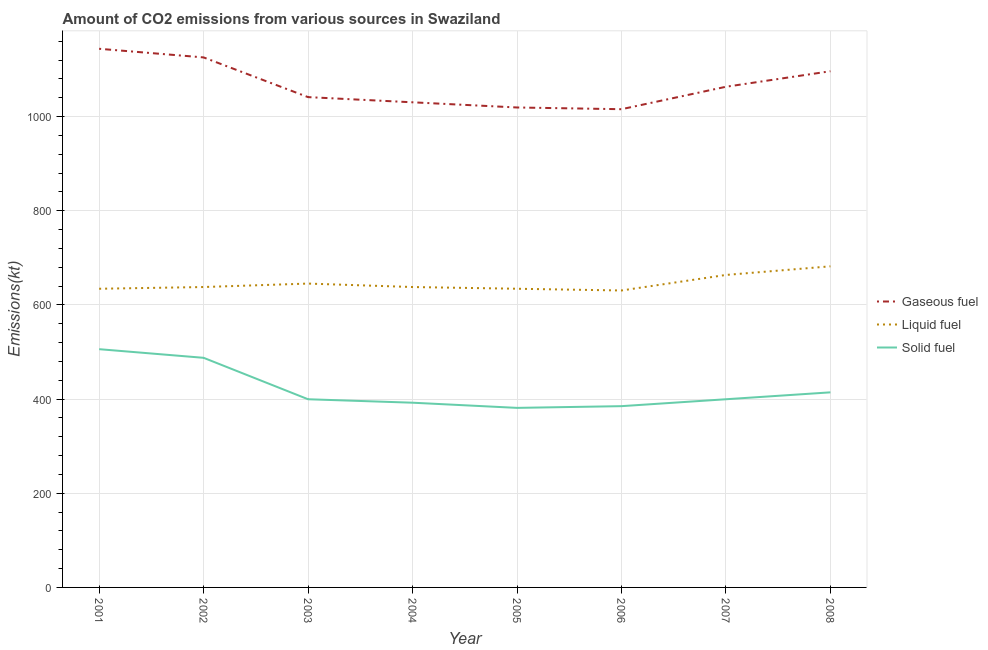How many different coloured lines are there?
Give a very brief answer. 3. Is the number of lines equal to the number of legend labels?
Your answer should be compact. Yes. What is the amount of co2 emissions from solid fuel in 2001?
Keep it short and to the point. 506.05. Across all years, what is the maximum amount of co2 emissions from liquid fuel?
Give a very brief answer. 682.06. Across all years, what is the minimum amount of co2 emissions from gaseous fuel?
Provide a succinct answer. 1015.76. In which year was the amount of co2 emissions from solid fuel maximum?
Offer a very short reply. 2001. In which year was the amount of co2 emissions from solid fuel minimum?
Your answer should be compact. 2005. What is the total amount of co2 emissions from solid fuel in the graph?
Offer a terse response. 3366.31. What is the difference between the amount of co2 emissions from solid fuel in 2003 and that in 2005?
Offer a very short reply. 18.33. What is the difference between the amount of co2 emissions from gaseous fuel in 2007 and the amount of co2 emissions from liquid fuel in 2006?
Offer a terse response. 432.71. What is the average amount of co2 emissions from gaseous fuel per year?
Your answer should be compact. 1067.1. In the year 2003, what is the difference between the amount of co2 emissions from gaseous fuel and amount of co2 emissions from liquid fuel?
Offer a very short reply. 396.04. In how many years, is the amount of co2 emissions from liquid fuel greater than 1000 kt?
Keep it short and to the point. 0. What is the ratio of the amount of co2 emissions from liquid fuel in 2002 to that in 2004?
Your response must be concise. 1. What is the difference between the highest and the second highest amount of co2 emissions from solid fuel?
Your answer should be compact. 18.33. What is the difference between the highest and the lowest amount of co2 emissions from gaseous fuel?
Offer a very short reply. 128.35. Is it the case that in every year, the sum of the amount of co2 emissions from gaseous fuel and amount of co2 emissions from liquid fuel is greater than the amount of co2 emissions from solid fuel?
Give a very brief answer. Yes. How many lines are there?
Make the answer very short. 3. How many years are there in the graph?
Offer a terse response. 8. What is the difference between two consecutive major ticks on the Y-axis?
Keep it short and to the point. 200. Are the values on the major ticks of Y-axis written in scientific E-notation?
Provide a short and direct response. No. Where does the legend appear in the graph?
Keep it short and to the point. Center right. How are the legend labels stacked?
Offer a terse response. Vertical. What is the title of the graph?
Give a very brief answer. Amount of CO2 emissions from various sources in Swaziland. What is the label or title of the Y-axis?
Your answer should be compact. Emissions(kt). What is the Emissions(kt) in Gaseous fuel in 2001?
Your response must be concise. 1144.1. What is the Emissions(kt) in Liquid fuel in 2001?
Offer a very short reply. 634.39. What is the Emissions(kt) of Solid fuel in 2001?
Ensure brevity in your answer.  506.05. What is the Emissions(kt) in Gaseous fuel in 2002?
Provide a succinct answer. 1125.77. What is the Emissions(kt) in Liquid fuel in 2002?
Offer a very short reply. 638.06. What is the Emissions(kt) of Solid fuel in 2002?
Your answer should be very brief. 487.71. What is the Emissions(kt) in Gaseous fuel in 2003?
Your response must be concise. 1041.43. What is the Emissions(kt) of Liquid fuel in 2003?
Provide a succinct answer. 645.39. What is the Emissions(kt) in Solid fuel in 2003?
Make the answer very short. 399.7. What is the Emissions(kt) of Gaseous fuel in 2004?
Make the answer very short. 1030.43. What is the Emissions(kt) of Liquid fuel in 2004?
Give a very brief answer. 638.06. What is the Emissions(kt) in Solid fuel in 2004?
Provide a succinct answer. 392.37. What is the Emissions(kt) in Gaseous fuel in 2005?
Provide a short and direct response. 1019.43. What is the Emissions(kt) of Liquid fuel in 2005?
Ensure brevity in your answer.  634.39. What is the Emissions(kt) in Solid fuel in 2005?
Give a very brief answer. 381.37. What is the Emissions(kt) in Gaseous fuel in 2006?
Provide a succinct answer. 1015.76. What is the Emissions(kt) of Liquid fuel in 2006?
Provide a succinct answer. 630.72. What is the Emissions(kt) in Solid fuel in 2006?
Your response must be concise. 385.04. What is the Emissions(kt) in Gaseous fuel in 2007?
Offer a terse response. 1063.43. What is the Emissions(kt) in Liquid fuel in 2007?
Ensure brevity in your answer.  663.73. What is the Emissions(kt) in Solid fuel in 2007?
Give a very brief answer. 399.7. What is the Emissions(kt) of Gaseous fuel in 2008?
Ensure brevity in your answer.  1096.43. What is the Emissions(kt) in Liquid fuel in 2008?
Make the answer very short. 682.06. What is the Emissions(kt) in Solid fuel in 2008?
Give a very brief answer. 414.37. Across all years, what is the maximum Emissions(kt) of Gaseous fuel?
Keep it short and to the point. 1144.1. Across all years, what is the maximum Emissions(kt) of Liquid fuel?
Your answer should be very brief. 682.06. Across all years, what is the maximum Emissions(kt) in Solid fuel?
Ensure brevity in your answer.  506.05. Across all years, what is the minimum Emissions(kt) of Gaseous fuel?
Your answer should be very brief. 1015.76. Across all years, what is the minimum Emissions(kt) in Liquid fuel?
Offer a very short reply. 630.72. Across all years, what is the minimum Emissions(kt) of Solid fuel?
Ensure brevity in your answer.  381.37. What is the total Emissions(kt) of Gaseous fuel in the graph?
Provide a short and direct response. 8536.78. What is the total Emissions(kt) in Liquid fuel in the graph?
Make the answer very short. 5166.8. What is the total Emissions(kt) in Solid fuel in the graph?
Ensure brevity in your answer.  3366.31. What is the difference between the Emissions(kt) of Gaseous fuel in 2001 and that in 2002?
Provide a succinct answer. 18.34. What is the difference between the Emissions(kt) in Liquid fuel in 2001 and that in 2002?
Your answer should be very brief. -3.67. What is the difference between the Emissions(kt) of Solid fuel in 2001 and that in 2002?
Give a very brief answer. 18.34. What is the difference between the Emissions(kt) in Gaseous fuel in 2001 and that in 2003?
Offer a very short reply. 102.68. What is the difference between the Emissions(kt) of Liquid fuel in 2001 and that in 2003?
Keep it short and to the point. -11. What is the difference between the Emissions(kt) of Solid fuel in 2001 and that in 2003?
Offer a very short reply. 106.34. What is the difference between the Emissions(kt) in Gaseous fuel in 2001 and that in 2004?
Your answer should be compact. 113.68. What is the difference between the Emissions(kt) in Liquid fuel in 2001 and that in 2004?
Offer a terse response. -3.67. What is the difference between the Emissions(kt) of Solid fuel in 2001 and that in 2004?
Make the answer very short. 113.68. What is the difference between the Emissions(kt) in Gaseous fuel in 2001 and that in 2005?
Keep it short and to the point. 124.68. What is the difference between the Emissions(kt) of Liquid fuel in 2001 and that in 2005?
Ensure brevity in your answer.  0. What is the difference between the Emissions(kt) of Solid fuel in 2001 and that in 2005?
Ensure brevity in your answer.  124.68. What is the difference between the Emissions(kt) of Gaseous fuel in 2001 and that in 2006?
Your answer should be very brief. 128.34. What is the difference between the Emissions(kt) of Liquid fuel in 2001 and that in 2006?
Your response must be concise. 3.67. What is the difference between the Emissions(kt) in Solid fuel in 2001 and that in 2006?
Offer a terse response. 121.01. What is the difference between the Emissions(kt) in Gaseous fuel in 2001 and that in 2007?
Offer a terse response. 80.67. What is the difference between the Emissions(kt) of Liquid fuel in 2001 and that in 2007?
Make the answer very short. -29.34. What is the difference between the Emissions(kt) of Solid fuel in 2001 and that in 2007?
Ensure brevity in your answer.  106.34. What is the difference between the Emissions(kt) in Gaseous fuel in 2001 and that in 2008?
Your response must be concise. 47.67. What is the difference between the Emissions(kt) in Liquid fuel in 2001 and that in 2008?
Your answer should be compact. -47.67. What is the difference between the Emissions(kt) of Solid fuel in 2001 and that in 2008?
Ensure brevity in your answer.  91.67. What is the difference between the Emissions(kt) of Gaseous fuel in 2002 and that in 2003?
Your answer should be very brief. 84.34. What is the difference between the Emissions(kt) in Liquid fuel in 2002 and that in 2003?
Provide a short and direct response. -7.33. What is the difference between the Emissions(kt) in Solid fuel in 2002 and that in 2003?
Ensure brevity in your answer.  88.01. What is the difference between the Emissions(kt) in Gaseous fuel in 2002 and that in 2004?
Your answer should be very brief. 95.34. What is the difference between the Emissions(kt) in Solid fuel in 2002 and that in 2004?
Offer a very short reply. 95.34. What is the difference between the Emissions(kt) of Gaseous fuel in 2002 and that in 2005?
Your answer should be very brief. 106.34. What is the difference between the Emissions(kt) of Liquid fuel in 2002 and that in 2005?
Provide a short and direct response. 3.67. What is the difference between the Emissions(kt) of Solid fuel in 2002 and that in 2005?
Keep it short and to the point. 106.34. What is the difference between the Emissions(kt) of Gaseous fuel in 2002 and that in 2006?
Make the answer very short. 110.01. What is the difference between the Emissions(kt) in Liquid fuel in 2002 and that in 2006?
Your answer should be compact. 7.33. What is the difference between the Emissions(kt) in Solid fuel in 2002 and that in 2006?
Give a very brief answer. 102.68. What is the difference between the Emissions(kt) in Gaseous fuel in 2002 and that in 2007?
Ensure brevity in your answer.  62.34. What is the difference between the Emissions(kt) in Liquid fuel in 2002 and that in 2007?
Keep it short and to the point. -25.67. What is the difference between the Emissions(kt) of Solid fuel in 2002 and that in 2007?
Offer a terse response. 88.01. What is the difference between the Emissions(kt) of Gaseous fuel in 2002 and that in 2008?
Make the answer very short. 29.34. What is the difference between the Emissions(kt) of Liquid fuel in 2002 and that in 2008?
Give a very brief answer. -44. What is the difference between the Emissions(kt) in Solid fuel in 2002 and that in 2008?
Your answer should be very brief. 73.34. What is the difference between the Emissions(kt) in Gaseous fuel in 2003 and that in 2004?
Offer a terse response. 11. What is the difference between the Emissions(kt) of Liquid fuel in 2003 and that in 2004?
Your answer should be compact. 7.33. What is the difference between the Emissions(kt) in Solid fuel in 2003 and that in 2004?
Make the answer very short. 7.33. What is the difference between the Emissions(kt) of Gaseous fuel in 2003 and that in 2005?
Ensure brevity in your answer.  22. What is the difference between the Emissions(kt) of Liquid fuel in 2003 and that in 2005?
Make the answer very short. 11. What is the difference between the Emissions(kt) of Solid fuel in 2003 and that in 2005?
Provide a short and direct response. 18.34. What is the difference between the Emissions(kt) of Gaseous fuel in 2003 and that in 2006?
Keep it short and to the point. 25.67. What is the difference between the Emissions(kt) in Liquid fuel in 2003 and that in 2006?
Your response must be concise. 14.67. What is the difference between the Emissions(kt) in Solid fuel in 2003 and that in 2006?
Keep it short and to the point. 14.67. What is the difference between the Emissions(kt) of Gaseous fuel in 2003 and that in 2007?
Give a very brief answer. -22. What is the difference between the Emissions(kt) in Liquid fuel in 2003 and that in 2007?
Ensure brevity in your answer.  -18.34. What is the difference between the Emissions(kt) in Gaseous fuel in 2003 and that in 2008?
Provide a succinct answer. -55.01. What is the difference between the Emissions(kt) in Liquid fuel in 2003 and that in 2008?
Offer a terse response. -36.67. What is the difference between the Emissions(kt) of Solid fuel in 2003 and that in 2008?
Your answer should be very brief. -14.67. What is the difference between the Emissions(kt) of Gaseous fuel in 2004 and that in 2005?
Your answer should be very brief. 11. What is the difference between the Emissions(kt) in Liquid fuel in 2004 and that in 2005?
Give a very brief answer. 3.67. What is the difference between the Emissions(kt) of Solid fuel in 2004 and that in 2005?
Your answer should be compact. 11. What is the difference between the Emissions(kt) in Gaseous fuel in 2004 and that in 2006?
Give a very brief answer. 14.67. What is the difference between the Emissions(kt) of Liquid fuel in 2004 and that in 2006?
Your answer should be very brief. 7.33. What is the difference between the Emissions(kt) in Solid fuel in 2004 and that in 2006?
Your response must be concise. 7.33. What is the difference between the Emissions(kt) in Gaseous fuel in 2004 and that in 2007?
Provide a short and direct response. -33. What is the difference between the Emissions(kt) in Liquid fuel in 2004 and that in 2007?
Keep it short and to the point. -25.67. What is the difference between the Emissions(kt) in Solid fuel in 2004 and that in 2007?
Your response must be concise. -7.33. What is the difference between the Emissions(kt) of Gaseous fuel in 2004 and that in 2008?
Offer a terse response. -66.01. What is the difference between the Emissions(kt) in Liquid fuel in 2004 and that in 2008?
Your answer should be very brief. -44. What is the difference between the Emissions(kt) in Solid fuel in 2004 and that in 2008?
Provide a short and direct response. -22. What is the difference between the Emissions(kt) in Gaseous fuel in 2005 and that in 2006?
Keep it short and to the point. 3.67. What is the difference between the Emissions(kt) of Liquid fuel in 2005 and that in 2006?
Provide a succinct answer. 3.67. What is the difference between the Emissions(kt) of Solid fuel in 2005 and that in 2006?
Make the answer very short. -3.67. What is the difference between the Emissions(kt) in Gaseous fuel in 2005 and that in 2007?
Your answer should be very brief. -44. What is the difference between the Emissions(kt) in Liquid fuel in 2005 and that in 2007?
Ensure brevity in your answer.  -29.34. What is the difference between the Emissions(kt) of Solid fuel in 2005 and that in 2007?
Offer a very short reply. -18.34. What is the difference between the Emissions(kt) in Gaseous fuel in 2005 and that in 2008?
Make the answer very short. -77.01. What is the difference between the Emissions(kt) in Liquid fuel in 2005 and that in 2008?
Provide a short and direct response. -47.67. What is the difference between the Emissions(kt) of Solid fuel in 2005 and that in 2008?
Offer a terse response. -33. What is the difference between the Emissions(kt) in Gaseous fuel in 2006 and that in 2007?
Ensure brevity in your answer.  -47.67. What is the difference between the Emissions(kt) in Liquid fuel in 2006 and that in 2007?
Provide a succinct answer. -33. What is the difference between the Emissions(kt) in Solid fuel in 2006 and that in 2007?
Ensure brevity in your answer.  -14.67. What is the difference between the Emissions(kt) in Gaseous fuel in 2006 and that in 2008?
Offer a very short reply. -80.67. What is the difference between the Emissions(kt) of Liquid fuel in 2006 and that in 2008?
Provide a succinct answer. -51.34. What is the difference between the Emissions(kt) in Solid fuel in 2006 and that in 2008?
Give a very brief answer. -29.34. What is the difference between the Emissions(kt) in Gaseous fuel in 2007 and that in 2008?
Offer a very short reply. -33. What is the difference between the Emissions(kt) of Liquid fuel in 2007 and that in 2008?
Your answer should be very brief. -18.34. What is the difference between the Emissions(kt) in Solid fuel in 2007 and that in 2008?
Your response must be concise. -14.67. What is the difference between the Emissions(kt) in Gaseous fuel in 2001 and the Emissions(kt) in Liquid fuel in 2002?
Your answer should be compact. 506.05. What is the difference between the Emissions(kt) of Gaseous fuel in 2001 and the Emissions(kt) of Solid fuel in 2002?
Offer a very short reply. 656.39. What is the difference between the Emissions(kt) in Liquid fuel in 2001 and the Emissions(kt) in Solid fuel in 2002?
Provide a short and direct response. 146.68. What is the difference between the Emissions(kt) of Gaseous fuel in 2001 and the Emissions(kt) of Liquid fuel in 2003?
Keep it short and to the point. 498.71. What is the difference between the Emissions(kt) of Gaseous fuel in 2001 and the Emissions(kt) of Solid fuel in 2003?
Make the answer very short. 744.4. What is the difference between the Emissions(kt) in Liquid fuel in 2001 and the Emissions(kt) in Solid fuel in 2003?
Keep it short and to the point. 234.69. What is the difference between the Emissions(kt) of Gaseous fuel in 2001 and the Emissions(kt) of Liquid fuel in 2004?
Provide a short and direct response. 506.05. What is the difference between the Emissions(kt) of Gaseous fuel in 2001 and the Emissions(kt) of Solid fuel in 2004?
Make the answer very short. 751.74. What is the difference between the Emissions(kt) in Liquid fuel in 2001 and the Emissions(kt) in Solid fuel in 2004?
Give a very brief answer. 242.02. What is the difference between the Emissions(kt) of Gaseous fuel in 2001 and the Emissions(kt) of Liquid fuel in 2005?
Keep it short and to the point. 509.71. What is the difference between the Emissions(kt) of Gaseous fuel in 2001 and the Emissions(kt) of Solid fuel in 2005?
Give a very brief answer. 762.74. What is the difference between the Emissions(kt) in Liquid fuel in 2001 and the Emissions(kt) in Solid fuel in 2005?
Make the answer very short. 253.02. What is the difference between the Emissions(kt) of Gaseous fuel in 2001 and the Emissions(kt) of Liquid fuel in 2006?
Your answer should be very brief. 513.38. What is the difference between the Emissions(kt) in Gaseous fuel in 2001 and the Emissions(kt) in Solid fuel in 2006?
Keep it short and to the point. 759.07. What is the difference between the Emissions(kt) in Liquid fuel in 2001 and the Emissions(kt) in Solid fuel in 2006?
Give a very brief answer. 249.36. What is the difference between the Emissions(kt) in Gaseous fuel in 2001 and the Emissions(kt) in Liquid fuel in 2007?
Offer a very short reply. 480.38. What is the difference between the Emissions(kt) in Gaseous fuel in 2001 and the Emissions(kt) in Solid fuel in 2007?
Offer a terse response. 744.4. What is the difference between the Emissions(kt) of Liquid fuel in 2001 and the Emissions(kt) of Solid fuel in 2007?
Make the answer very short. 234.69. What is the difference between the Emissions(kt) in Gaseous fuel in 2001 and the Emissions(kt) in Liquid fuel in 2008?
Keep it short and to the point. 462.04. What is the difference between the Emissions(kt) in Gaseous fuel in 2001 and the Emissions(kt) in Solid fuel in 2008?
Make the answer very short. 729.73. What is the difference between the Emissions(kt) of Liquid fuel in 2001 and the Emissions(kt) of Solid fuel in 2008?
Give a very brief answer. 220.02. What is the difference between the Emissions(kt) in Gaseous fuel in 2002 and the Emissions(kt) in Liquid fuel in 2003?
Keep it short and to the point. 480.38. What is the difference between the Emissions(kt) of Gaseous fuel in 2002 and the Emissions(kt) of Solid fuel in 2003?
Your answer should be very brief. 726.07. What is the difference between the Emissions(kt) in Liquid fuel in 2002 and the Emissions(kt) in Solid fuel in 2003?
Provide a short and direct response. 238.35. What is the difference between the Emissions(kt) in Gaseous fuel in 2002 and the Emissions(kt) in Liquid fuel in 2004?
Offer a terse response. 487.71. What is the difference between the Emissions(kt) in Gaseous fuel in 2002 and the Emissions(kt) in Solid fuel in 2004?
Your answer should be very brief. 733.4. What is the difference between the Emissions(kt) in Liquid fuel in 2002 and the Emissions(kt) in Solid fuel in 2004?
Make the answer very short. 245.69. What is the difference between the Emissions(kt) of Gaseous fuel in 2002 and the Emissions(kt) of Liquid fuel in 2005?
Your answer should be compact. 491.38. What is the difference between the Emissions(kt) in Gaseous fuel in 2002 and the Emissions(kt) in Solid fuel in 2005?
Offer a very short reply. 744.4. What is the difference between the Emissions(kt) in Liquid fuel in 2002 and the Emissions(kt) in Solid fuel in 2005?
Your response must be concise. 256.69. What is the difference between the Emissions(kt) in Gaseous fuel in 2002 and the Emissions(kt) in Liquid fuel in 2006?
Offer a very short reply. 495.05. What is the difference between the Emissions(kt) of Gaseous fuel in 2002 and the Emissions(kt) of Solid fuel in 2006?
Provide a short and direct response. 740.73. What is the difference between the Emissions(kt) of Liquid fuel in 2002 and the Emissions(kt) of Solid fuel in 2006?
Keep it short and to the point. 253.02. What is the difference between the Emissions(kt) of Gaseous fuel in 2002 and the Emissions(kt) of Liquid fuel in 2007?
Offer a terse response. 462.04. What is the difference between the Emissions(kt) of Gaseous fuel in 2002 and the Emissions(kt) of Solid fuel in 2007?
Make the answer very short. 726.07. What is the difference between the Emissions(kt) in Liquid fuel in 2002 and the Emissions(kt) in Solid fuel in 2007?
Keep it short and to the point. 238.35. What is the difference between the Emissions(kt) in Gaseous fuel in 2002 and the Emissions(kt) in Liquid fuel in 2008?
Provide a succinct answer. 443.71. What is the difference between the Emissions(kt) of Gaseous fuel in 2002 and the Emissions(kt) of Solid fuel in 2008?
Offer a terse response. 711.4. What is the difference between the Emissions(kt) of Liquid fuel in 2002 and the Emissions(kt) of Solid fuel in 2008?
Your response must be concise. 223.69. What is the difference between the Emissions(kt) of Gaseous fuel in 2003 and the Emissions(kt) of Liquid fuel in 2004?
Provide a short and direct response. 403.37. What is the difference between the Emissions(kt) of Gaseous fuel in 2003 and the Emissions(kt) of Solid fuel in 2004?
Keep it short and to the point. 649.06. What is the difference between the Emissions(kt) of Liquid fuel in 2003 and the Emissions(kt) of Solid fuel in 2004?
Provide a succinct answer. 253.02. What is the difference between the Emissions(kt) in Gaseous fuel in 2003 and the Emissions(kt) in Liquid fuel in 2005?
Your response must be concise. 407.04. What is the difference between the Emissions(kt) of Gaseous fuel in 2003 and the Emissions(kt) of Solid fuel in 2005?
Your response must be concise. 660.06. What is the difference between the Emissions(kt) of Liquid fuel in 2003 and the Emissions(kt) of Solid fuel in 2005?
Keep it short and to the point. 264.02. What is the difference between the Emissions(kt) of Gaseous fuel in 2003 and the Emissions(kt) of Liquid fuel in 2006?
Make the answer very short. 410.7. What is the difference between the Emissions(kt) in Gaseous fuel in 2003 and the Emissions(kt) in Solid fuel in 2006?
Offer a very short reply. 656.39. What is the difference between the Emissions(kt) of Liquid fuel in 2003 and the Emissions(kt) of Solid fuel in 2006?
Give a very brief answer. 260.36. What is the difference between the Emissions(kt) of Gaseous fuel in 2003 and the Emissions(kt) of Liquid fuel in 2007?
Ensure brevity in your answer.  377.7. What is the difference between the Emissions(kt) in Gaseous fuel in 2003 and the Emissions(kt) in Solid fuel in 2007?
Your response must be concise. 641.73. What is the difference between the Emissions(kt) of Liquid fuel in 2003 and the Emissions(kt) of Solid fuel in 2007?
Offer a very short reply. 245.69. What is the difference between the Emissions(kt) in Gaseous fuel in 2003 and the Emissions(kt) in Liquid fuel in 2008?
Your answer should be very brief. 359.37. What is the difference between the Emissions(kt) in Gaseous fuel in 2003 and the Emissions(kt) in Solid fuel in 2008?
Give a very brief answer. 627.06. What is the difference between the Emissions(kt) in Liquid fuel in 2003 and the Emissions(kt) in Solid fuel in 2008?
Your answer should be very brief. 231.02. What is the difference between the Emissions(kt) in Gaseous fuel in 2004 and the Emissions(kt) in Liquid fuel in 2005?
Your answer should be very brief. 396.04. What is the difference between the Emissions(kt) in Gaseous fuel in 2004 and the Emissions(kt) in Solid fuel in 2005?
Your answer should be compact. 649.06. What is the difference between the Emissions(kt) in Liquid fuel in 2004 and the Emissions(kt) in Solid fuel in 2005?
Provide a succinct answer. 256.69. What is the difference between the Emissions(kt) in Gaseous fuel in 2004 and the Emissions(kt) in Liquid fuel in 2006?
Your answer should be compact. 399.7. What is the difference between the Emissions(kt) in Gaseous fuel in 2004 and the Emissions(kt) in Solid fuel in 2006?
Give a very brief answer. 645.39. What is the difference between the Emissions(kt) of Liquid fuel in 2004 and the Emissions(kt) of Solid fuel in 2006?
Offer a very short reply. 253.02. What is the difference between the Emissions(kt) of Gaseous fuel in 2004 and the Emissions(kt) of Liquid fuel in 2007?
Offer a terse response. 366.7. What is the difference between the Emissions(kt) in Gaseous fuel in 2004 and the Emissions(kt) in Solid fuel in 2007?
Your response must be concise. 630.72. What is the difference between the Emissions(kt) in Liquid fuel in 2004 and the Emissions(kt) in Solid fuel in 2007?
Give a very brief answer. 238.35. What is the difference between the Emissions(kt) of Gaseous fuel in 2004 and the Emissions(kt) of Liquid fuel in 2008?
Provide a short and direct response. 348.37. What is the difference between the Emissions(kt) in Gaseous fuel in 2004 and the Emissions(kt) in Solid fuel in 2008?
Give a very brief answer. 616.06. What is the difference between the Emissions(kt) in Liquid fuel in 2004 and the Emissions(kt) in Solid fuel in 2008?
Ensure brevity in your answer.  223.69. What is the difference between the Emissions(kt) of Gaseous fuel in 2005 and the Emissions(kt) of Liquid fuel in 2006?
Give a very brief answer. 388.7. What is the difference between the Emissions(kt) of Gaseous fuel in 2005 and the Emissions(kt) of Solid fuel in 2006?
Offer a terse response. 634.39. What is the difference between the Emissions(kt) of Liquid fuel in 2005 and the Emissions(kt) of Solid fuel in 2006?
Make the answer very short. 249.36. What is the difference between the Emissions(kt) of Gaseous fuel in 2005 and the Emissions(kt) of Liquid fuel in 2007?
Your answer should be very brief. 355.7. What is the difference between the Emissions(kt) of Gaseous fuel in 2005 and the Emissions(kt) of Solid fuel in 2007?
Provide a short and direct response. 619.72. What is the difference between the Emissions(kt) in Liquid fuel in 2005 and the Emissions(kt) in Solid fuel in 2007?
Offer a terse response. 234.69. What is the difference between the Emissions(kt) in Gaseous fuel in 2005 and the Emissions(kt) in Liquid fuel in 2008?
Offer a terse response. 337.36. What is the difference between the Emissions(kt) of Gaseous fuel in 2005 and the Emissions(kt) of Solid fuel in 2008?
Your response must be concise. 605.05. What is the difference between the Emissions(kt) of Liquid fuel in 2005 and the Emissions(kt) of Solid fuel in 2008?
Offer a very short reply. 220.02. What is the difference between the Emissions(kt) of Gaseous fuel in 2006 and the Emissions(kt) of Liquid fuel in 2007?
Make the answer very short. 352.03. What is the difference between the Emissions(kt) of Gaseous fuel in 2006 and the Emissions(kt) of Solid fuel in 2007?
Your answer should be very brief. 616.06. What is the difference between the Emissions(kt) of Liquid fuel in 2006 and the Emissions(kt) of Solid fuel in 2007?
Provide a short and direct response. 231.02. What is the difference between the Emissions(kt) in Gaseous fuel in 2006 and the Emissions(kt) in Liquid fuel in 2008?
Ensure brevity in your answer.  333.7. What is the difference between the Emissions(kt) in Gaseous fuel in 2006 and the Emissions(kt) in Solid fuel in 2008?
Offer a terse response. 601.39. What is the difference between the Emissions(kt) in Liquid fuel in 2006 and the Emissions(kt) in Solid fuel in 2008?
Offer a terse response. 216.35. What is the difference between the Emissions(kt) of Gaseous fuel in 2007 and the Emissions(kt) of Liquid fuel in 2008?
Give a very brief answer. 381.37. What is the difference between the Emissions(kt) of Gaseous fuel in 2007 and the Emissions(kt) of Solid fuel in 2008?
Make the answer very short. 649.06. What is the difference between the Emissions(kt) in Liquid fuel in 2007 and the Emissions(kt) in Solid fuel in 2008?
Keep it short and to the point. 249.36. What is the average Emissions(kt) of Gaseous fuel per year?
Offer a very short reply. 1067.1. What is the average Emissions(kt) in Liquid fuel per year?
Make the answer very short. 645.85. What is the average Emissions(kt) in Solid fuel per year?
Your answer should be very brief. 420.79. In the year 2001, what is the difference between the Emissions(kt) of Gaseous fuel and Emissions(kt) of Liquid fuel?
Provide a short and direct response. 509.71. In the year 2001, what is the difference between the Emissions(kt) of Gaseous fuel and Emissions(kt) of Solid fuel?
Give a very brief answer. 638.06. In the year 2001, what is the difference between the Emissions(kt) of Liquid fuel and Emissions(kt) of Solid fuel?
Your answer should be compact. 128.34. In the year 2002, what is the difference between the Emissions(kt) in Gaseous fuel and Emissions(kt) in Liquid fuel?
Provide a short and direct response. 487.71. In the year 2002, what is the difference between the Emissions(kt) in Gaseous fuel and Emissions(kt) in Solid fuel?
Your answer should be very brief. 638.06. In the year 2002, what is the difference between the Emissions(kt) of Liquid fuel and Emissions(kt) of Solid fuel?
Ensure brevity in your answer.  150.35. In the year 2003, what is the difference between the Emissions(kt) of Gaseous fuel and Emissions(kt) of Liquid fuel?
Offer a very short reply. 396.04. In the year 2003, what is the difference between the Emissions(kt) in Gaseous fuel and Emissions(kt) in Solid fuel?
Your answer should be compact. 641.73. In the year 2003, what is the difference between the Emissions(kt) in Liquid fuel and Emissions(kt) in Solid fuel?
Your answer should be compact. 245.69. In the year 2004, what is the difference between the Emissions(kt) in Gaseous fuel and Emissions(kt) in Liquid fuel?
Provide a succinct answer. 392.37. In the year 2004, what is the difference between the Emissions(kt) of Gaseous fuel and Emissions(kt) of Solid fuel?
Offer a terse response. 638.06. In the year 2004, what is the difference between the Emissions(kt) of Liquid fuel and Emissions(kt) of Solid fuel?
Offer a terse response. 245.69. In the year 2005, what is the difference between the Emissions(kt) in Gaseous fuel and Emissions(kt) in Liquid fuel?
Provide a succinct answer. 385.04. In the year 2005, what is the difference between the Emissions(kt) in Gaseous fuel and Emissions(kt) in Solid fuel?
Keep it short and to the point. 638.06. In the year 2005, what is the difference between the Emissions(kt) in Liquid fuel and Emissions(kt) in Solid fuel?
Your answer should be very brief. 253.02. In the year 2006, what is the difference between the Emissions(kt) in Gaseous fuel and Emissions(kt) in Liquid fuel?
Provide a succinct answer. 385.04. In the year 2006, what is the difference between the Emissions(kt) of Gaseous fuel and Emissions(kt) of Solid fuel?
Your answer should be very brief. 630.72. In the year 2006, what is the difference between the Emissions(kt) in Liquid fuel and Emissions(kt) in Solid fuel?
Your answer should be compact. 245.69. In the year 2007, what is the difference between the Emissions(kt) in Gaseous fuel and Emissions(kt) in Liquid fuel?
Give a very brief answer. 399.7. In the year 2007, what is the difference between the Emissions(kt) in Gaseous fuel and Emissions(kt) in Solid fuel?
Offer a terse response. 663.73. In the year 2007, what is the difference between the Emissions(kt) in Liquid fuel and Emissions(kt) in Solid fuel?
Offer a terse response. 264.02. In the year 2008, what is the difference between the Emissions(kt) in Gaseous fuel and Emissions(kt) in Liquid fuel?
Offer a terse response. 414.37. In the year 2008, what is the difference between the Emissions(kt) in Gaseous fuel and Emissions(kt) in Solid fuel?
Give a very brief answer. 682.06. In the year 2008, what is the difference between the Emissions(kt) in Liquid fuel and Emissions(kt) in Solid fuel?
Make the answer very short. 267.69. What is the ratio of the Emissions(kt) of Gaseous fuel in 2001 to that in 2002?
Offer a very short reply. 1.02. What is the ratio of the Emissions(kt) in Liquid fuel in 2001 to that in 2002?
Your response must be concise. 0.99. What is the ratio of the Emissions(kt) of Solid fuel in 2001 to that in 2002?
Ensure brevity in your answer.  1.04. What is the ratio of the Emissions(kt) in Gaseous fuel in 2001 to that in 2003?
Ensure brevity in your answer.  1.1. What is the ratio of the Emissions(kt) in Liquid fuel in 2001 to that in 2003?
Your answer should be compact. 0.98. What is the ratio of the Emissions(kt) of Solid fuel in 2001 to that in 2003?
Ensure brevity in your answer.  1.27. What is the ratio of the Emissions(kt) in Gaseous fuel in 2001 to that in 2004?
Keep it short and to the point. 1.11. What is the ratio of the Emissions(kt) of Liquid fuel in 2001 to that in 2004?
Keep it short and to the point. 0.99. What is the ratio of the Emissions(kt) of Solid fuel in 2001 to that in 2004?
Offer a very short reply. 1.29. What is the ratio of the Emissions(kt) in Gaseous fuel in 2001 to that in 2005?
Keep it short and to the point. 1.12. What is the ratio of the Emissions(kt) in Solid fuel in 2001 to that in 2005?
Give a very brief answer. 1.33. What is the ratio of the Emissions(kt) of Gaseous fuel in 2001 to that in 2006?
Offer a terse response. 1.13. What is the ratio of the Emissions(kt) of Solid fuel in 2001 to that in 2006?
Make the answer very short. 1.31. What is the ratio of the Emissions(kt) of Gaseous fuel in 2001 to that in 2007?
Provide a succinct answer. 1.08. What is the ratio of the Emissions(kt) in Liquid fuel in 2001 to that in 2007?
Ensure brevity in your answer.  0.96. What is the ratio of the Emissions(kt) in Solid fuel in 2001 to that in 2007?
Your answer should be very brief. 1.27. What is the ratio of the Emissions(kt) in Gaseous fuel in 2001 to that in 2008?
Offer a terse response. 1.04. What is the ratio of the Emissions(kt) in Liquid fuel in 2001 to that in 2008?
Keep it short and to the point. 0.93. What is the ratio of the Emissions(kt) in Solid fuel in 2001 to that in 2008?
Your response must be concise. 1.22. What is the ratio of the Emissions(kt) of Gaseous fuel in 2002 to that in 2003?
Your response must be concise. 1.08. What is the ratio of the Emissions(kt) of Solid fuel in 2002 to that in 2003?
Offer a very short reply. 1.22. What is the ratio of the Emissions(kt) in Gaseous fuel in 2002 to that in 2004?
Provide a succinct answer. 1.09. What is the ratio of the Emissions(kt) of Solid fuel in 2002 to that in 2004?
Give a very brief answer. 1.24. What is the ratio of the Emissions(kt) of Gaseous fuel in 2002 to that in 2005?
Offer a very short reply. 1.1. What is the ratio of the Emissions(kt) of Liquid fuel in 2002 to that in 2005?
Provide a succinct answer. 1.01. What is the ratio of the Emissions(kt) in Solid fuel in 2002 to that in 2005?
Offer a very short reply. 1.28. What is the ratio of the Emissions(kt) of Gaseous fuel in 2002 to that in 2006?
Offer a terse response. 1.11. What is the ratio of the Emissions(kt) in Liquid fuel in 2002 to that in 2006?
Keep it short and to the point. 1.01. What is the ratio of the Emissions(kt) in Solid fuel in 2002 to that in 2006?
Make the answer very short. 1.27. What is the ratio of the Emissions(kt) in Gaseous fuel in 2002 to that in 2007?
Make the answer very short. 1.06. What is the ratio of the Emissions(kt) of Liquid fuel in 2002 to that in 2007?
Keep it short and to the point. 0.96. What is the ratio of the Emissions(kt) in Solid fuel in 2002 to that in 2007?
Your answer should be compact. 1.22. What is the ratio of the Emissions(kt) of Gaseous fuel in 2002 to that in 2008?
Give a very brief answer. 1.03. What is the ratio of the Emissions(kt) in Liquid fuel in 2002 to that in 2008?
Offer a terse response. 0.94. What is the ratio of the Emissions(kt) in Solid fuel in 2002 to that in 2008?
Make the answer very short. 1.18. What is the ratio of the Emissions(kt) of Gaseous fuel in 2003 to that in 2004?
Give a very brief answer. 1.01. What is the ratio of the Emissions(kt) in Liquid fuel in 2003 to that in 2004?
Keep it short and to the point. 1.01. What is the ratio of the Emissions(kt) in Solid fuel in 2003 to that in 2004?
Make the answer very short. 1.02. What is the ratio of the Emissions(kt) of Gaseous fuel in 2003 to that in 2005?
Provide a short and direct response. 1.02. What is the ratio of the Emissions(kt) in Liquid fuel in 2003 to that in 2005?
Your answer should be very brief. 1.02. What is the ratio of the Emissions(kt) in Solid fuel in 2003 to that in 2005?
Keep it short and to the point. 1.05. What is the ratio of the Emissions(kt) in Gaseous fuel in 2003 to that in 2006?
Offer a terse response. 1.03. What is the ratio of the Emissions(kt) in Liquid fuel in 2003 to that in 2006?
Give a very brief answer. 1.02. What is the ratio of the Emissions(kt) in Solid fuel in 2003 to that in 2006?
Ensure brevity in your answer.  1.04. What is the ratio of the Emissions(kt) in Gaseous fuel in 2003 to that in 2007?
Make the answer very short. 0.98. What is the ratio of the Emissions(kt) of Liquid fuel in 2003 to that in 2007?
Make the answer very short. 0.97. What is the ratio of the Emissions(kt) of Solid fuel in 2003 to that in 2007?
Provide a short and direct response. 1. What is the ratio of the Emissions(kt) of Gaseous fuel in 2003 to that in 2008?
Offer a very short reply. 0.95. What is the ratio of the Emissions(kt) of Liquid fuel in 2003 to that in 2008?
Provide a short and direct response. 0.95. What is the ratio of the Emissions(kt) of Solid fuel in 2003 to that in 2008?
Provide a short and direct response. 0.96. What is the ratio of the Emissions(kt) in Gaseous fuel in 2004 to that in 2005?
Keep it short and to the point. 1.01. What is the ratio of the Emissions(kt) of Liquid fuel in 2004 to that in 2005?
Offer a very short reply. 1.01. What is the ratio of the Emissions(kt) in Solid fuel in 2004 to that in 2005?
Your answer should be compact. 1.03. What is the ratio of the Emissions(kt) of Gaseous fuel in 2004 to that in 2006?
Make the answer very short. 1.01. What is the ratio of the Emissions(kt) of Liquid fuel in 2004 to that in 2006?
Provide a succinct answer. 1.01. What is the ratio of the Emissions(kt) of Liquid fuel in 2004 to that in 2007?
Ensure brevity in your answer.  0.96. What is the ratio of the Emissions(kt) in Solid fuel in 2004 to that in 2007?
Ensure brevity in your answer.  0.98. What is the ratio of the Emissions(kt) in Gaseous fuel in 2004 to that in 2008?
Your answer should be very brief. 0.94. What is the ratio of the Emissions(kt) in Liquid fuel in 2004 to that in 2008?
Offer a very short reply. 0.94. What is the ratio of the Emissions(kt) of Solid fuel in 2004 to that in 2008?
Provide a short and direct response. 0.95. What is the ratio of the Emissions(kt) of Gaseous fuel in 2005 to that in 2006?
Your response must be concise. 1. What is the ratio of the Emissions(kt) in Gaseous fuel in 2005 to that in 2007?
Your answer should be compact. 0.96. What is the ratio of the Emissions(kt) in Liquid fuel in 2005 to that in 2007?
Provide a short and direct response. 0.96. What is the ratio of the Emissions(kt) in Solid fuel in 2005 to that in 2007?
Your answer should be very brief. 0.95. What is the ratio of the Emissions(kt) in Gaseous fuel in 2005 to that in 2008?
Your answer should be very brief. 0.93. What is the ratio of the Emissions(kt) in Liquid fuel in 2005 to that in 2008?
Your answer should be compact. 0.93. What is the ratio of the Emissions(kt) in Solid fuel in 2005 to that in 2008?
Keep it short and to the point. 0.92. What is the ratio of the Emissions(kt) in Gaseous fuel in 2006 to that in 2007?
Keep it short and to the point. 0.96. What is the ratio of the Emissions(kt) of Liquid fuel in 2006 to that in 2007?
Keep it short and to the point. 0.95. What is the ratio of the Emissions(kt) in Solid fuel in 2006 to that in 2007?
Your response must be concise. 0.96. What is the ratio of the Emissions(kt) of Gaseous fuel in 2006 to that in 2008?
Offer a terse response. 0.93. What is the ratio of the Emissions(kt) in Liquid fuel in 2006 to that in 2008?
Your response must be concise. 0.92. What is the ratio of the Emissions(kt) of Solid fuel in 2006 to that in 2008?
Your answer should be very brief. 0.93. What is the ratio of the Emissions(kt) of Gaseous fuel in 2007 to that in 2008?
Keep it short and to the point. 0.97. What is the ratio of the Emissions(kt) of Liquid fuel in 2007 to that in 2008?
Your answer should be compact. 0.97. What is the ratio of the Emissions(kt) in Solid fuel in 2007 to that in 2008?
Ensure brevity in your answer.  0.96. What is the difference between the highest and the second highest Emissions(kt) in Gaseous fuel?
Ensure brevity in your answer.  18.34. What is the difference between the highest and the second highest Emissions(kt) of Liquid fuel?
Make the answer very short. 18.34. What is the difference between the highest and the second highest Emissions(kt) of Solid fuel?
Provide a short and direct response. 18.34. What is the difference between the highest and the lowest Emissions(kt) of Gaseous fuel?
Keep it short and to the point. 128.34. What is the difference between the highest and the lowest Emissions(kt) in Liquid fuel?
Your answer should be compact. 51.34. What is the difference between the highest and the lowest Emissions(kt) of Solid fuel?
Keep it short and to the point. 124.68. 